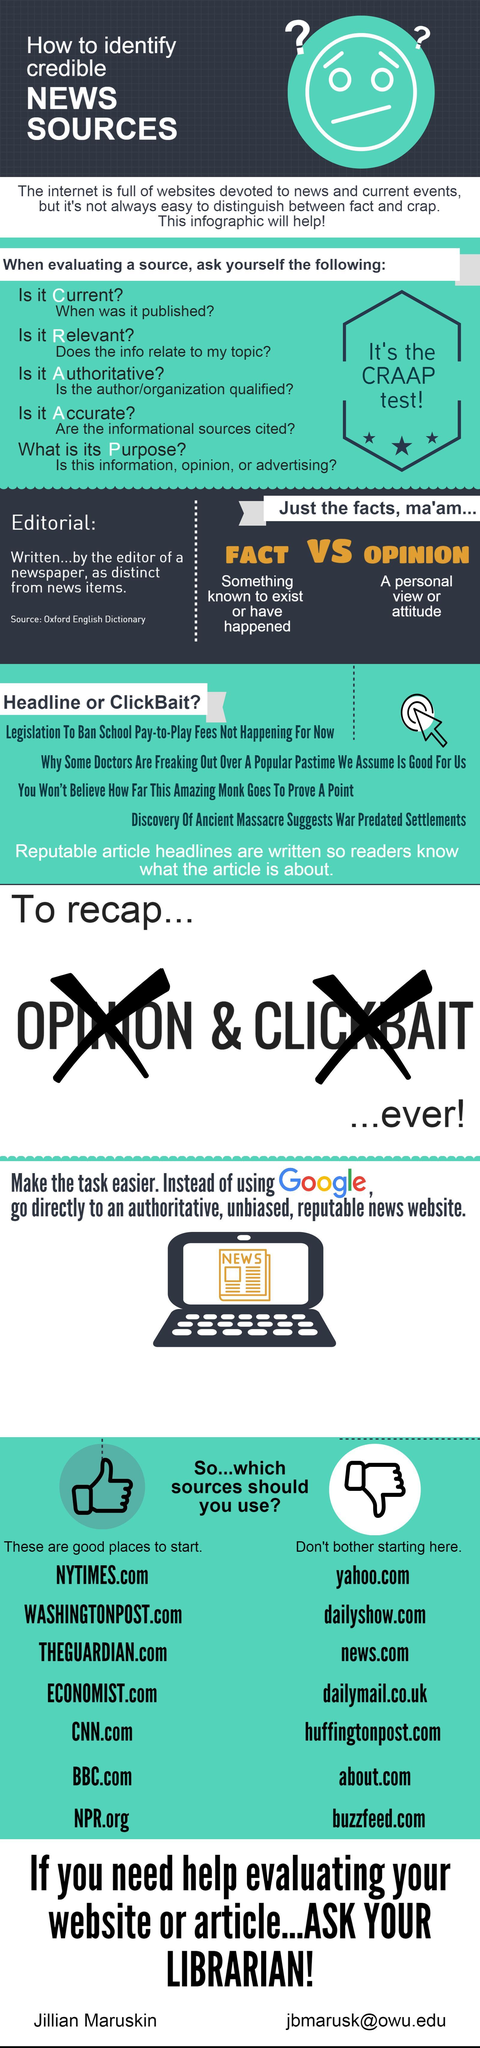Which word is written on the laptop?
Answer the question with a short phrase. News How many good sites to start? 7 